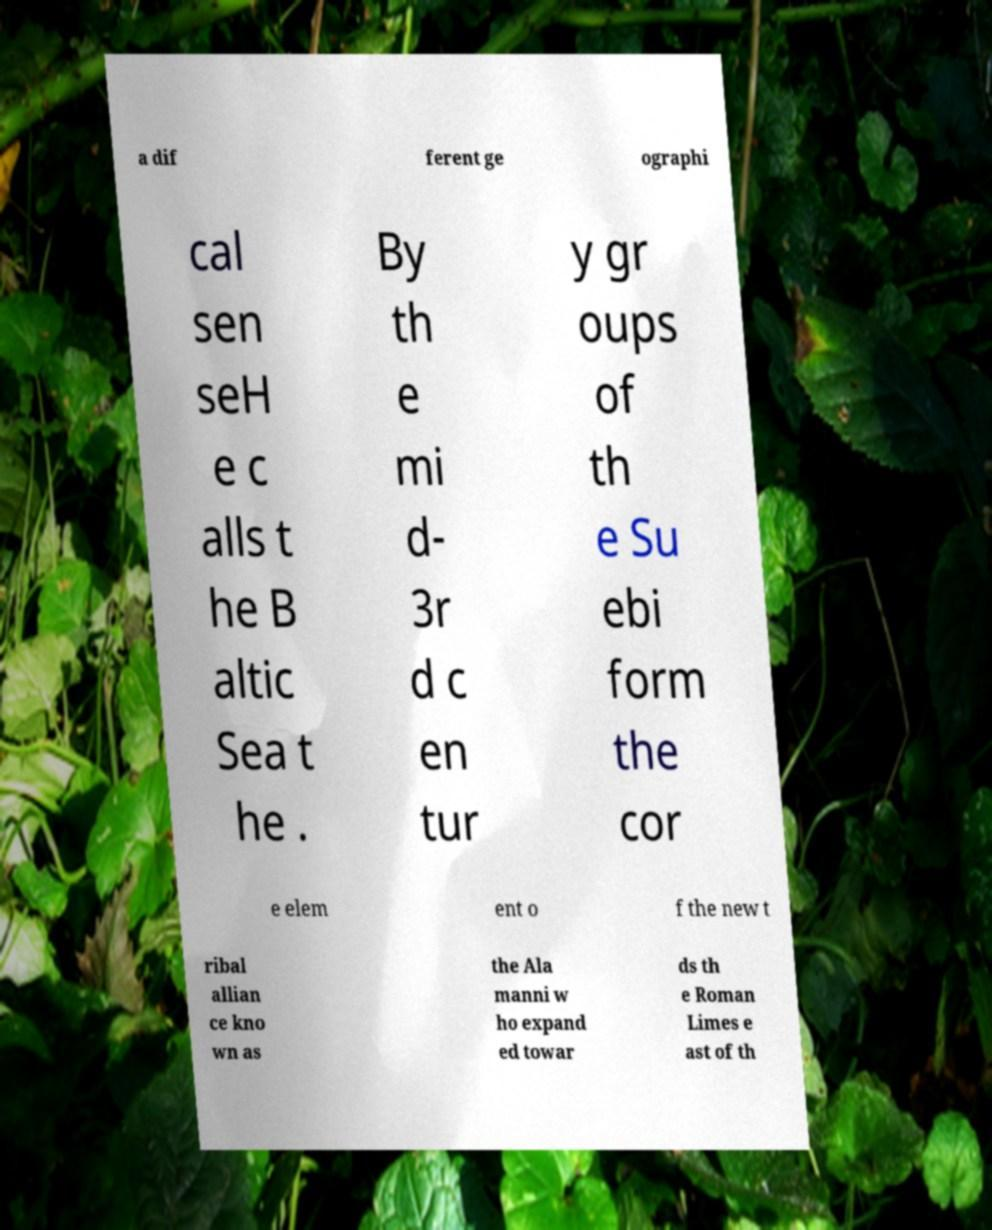There's text embedded in this image that I need extracted. Can you transcribe it verbatim? a dif ferent ge ographi cal sen seH e c alls t he B altic Sea t he . By th e mi d- 3r d c en tur y gr oups of th e Su ebi form the cor e elem ent o f the new t ribal allian ce kno wn as the Ala manni w ho expand ed towar ds th e Roman Limes e ast of th 